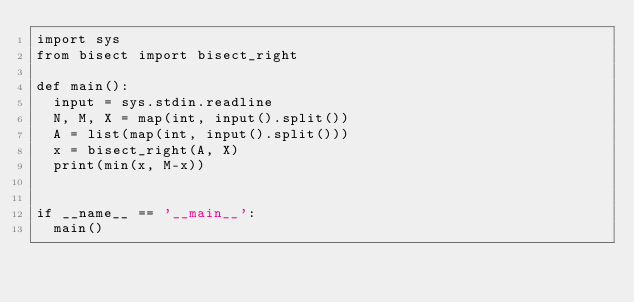Convert code to text. <code><loc_0><loc_0><loc_500><loc_500><_Python_>import sys
from bisect import bisect_right

def main():
  input = sys.stdin.readline
  N, M, X = map(int, input().split())
  A = list(map(int, input().split()))
  x = bisect_right(A, X)
  print(min(x, M-x))


if __name__ == '__main__':
  main()</code> 